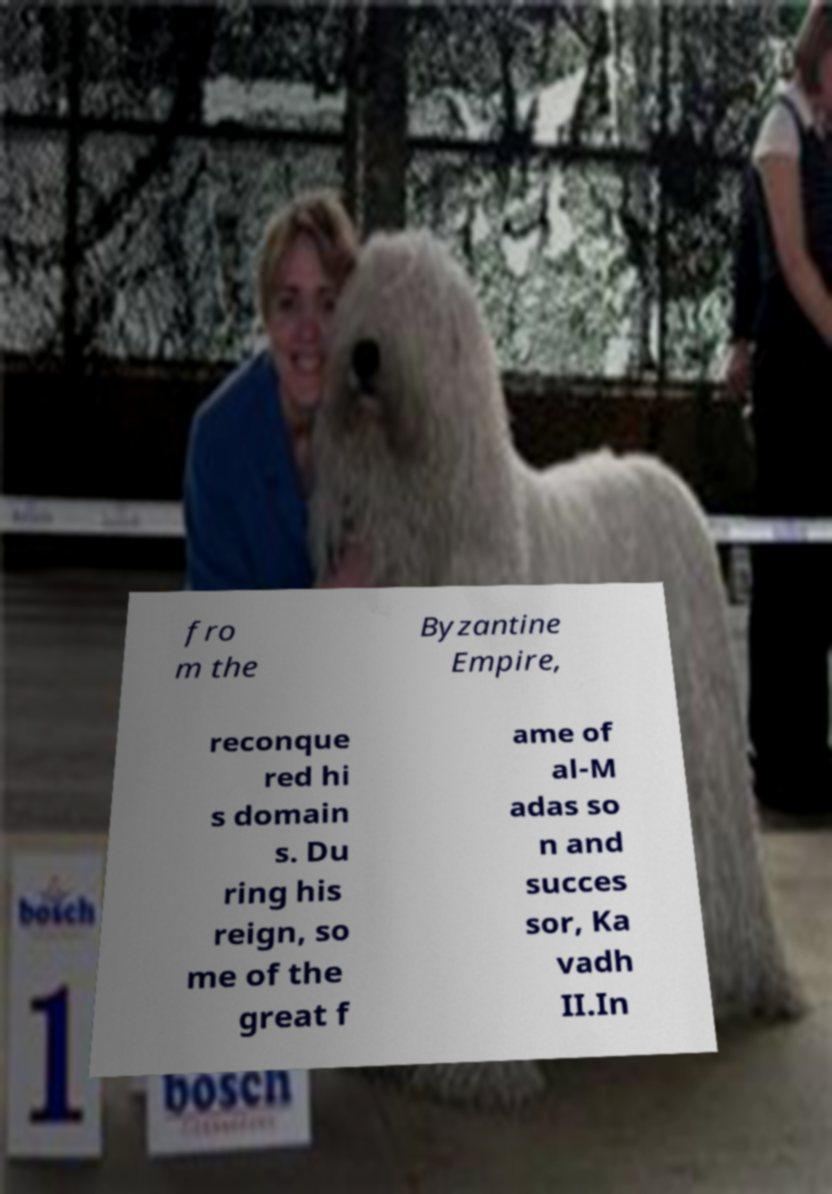Can you accurately transcribe the text from the provided image for me? fro m the Byzantine Empire, reconque red hi s domain s. Du ring his reign, so me of the great f ame of al-M adas so n and succes sor, Ka vadh II.In 